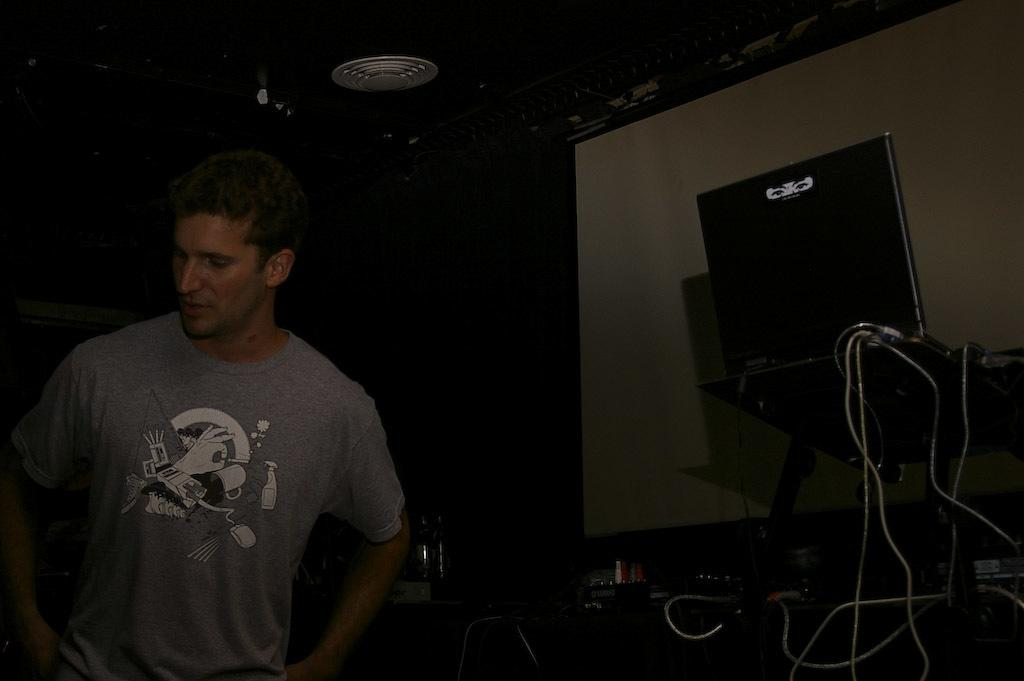Who is present in the image? There is a man in the image. What is the man doing in the image? The man is standing near electric substances. What can be seen in the image besides the man? There are wires and a screen on the wall in the image. What type of ink is being used by the deer in the image? There is no deer present in the image, and therefore no ink or ink-related activity can be observed. 